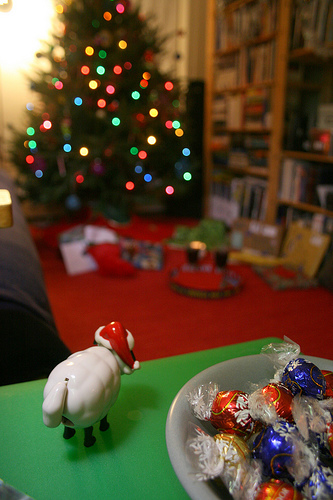<image>
Can you confirm if the sheep is on the table? Yes. Looking at the image, I can see the sheep is positioned on top of the table, with the table providing support. Is there a stocking under the tree? Yes. The stocking is positioned underneath the tree, with the tree above it in the vertical space. Is there a animal under the tree? No. The animal is not positioned under the tree. The vertical relationship between these objects is different. 